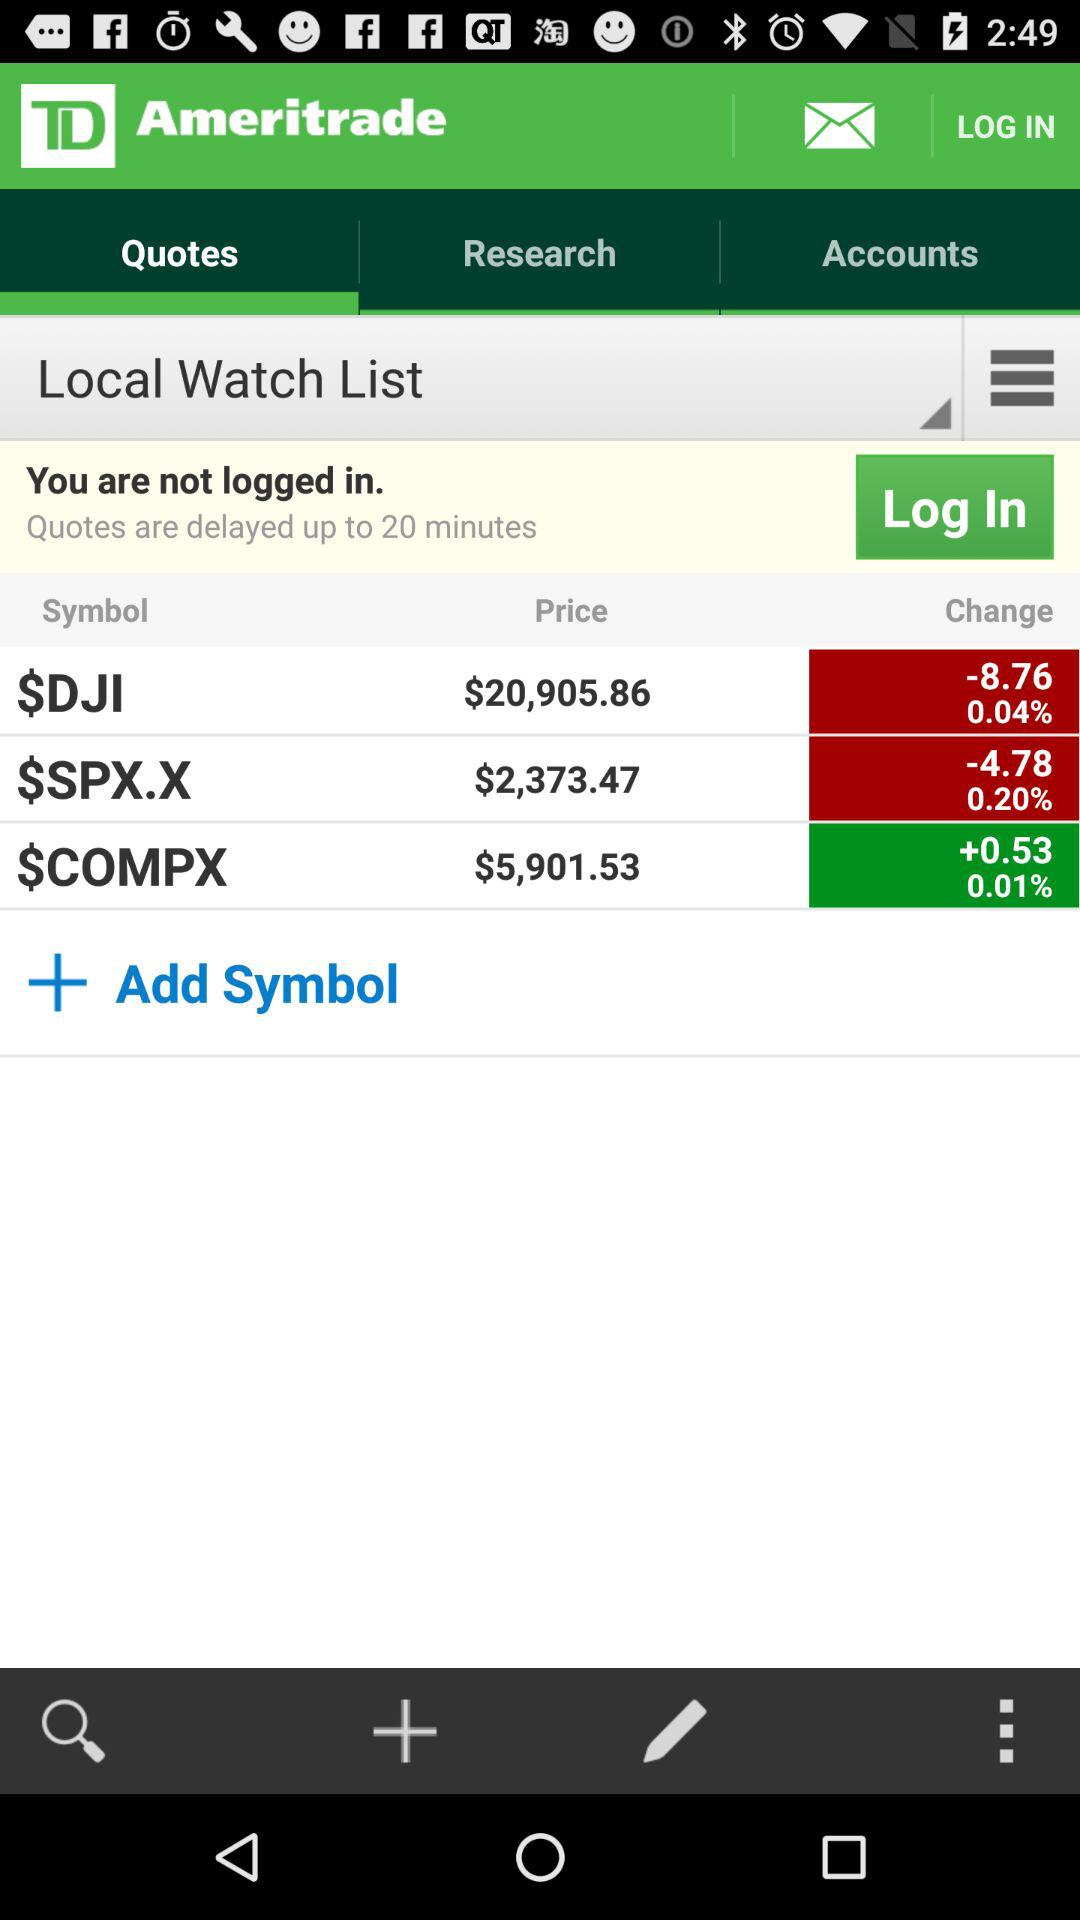How much is the percent change in $DJI? The percent change in $DJI is 0.04. 